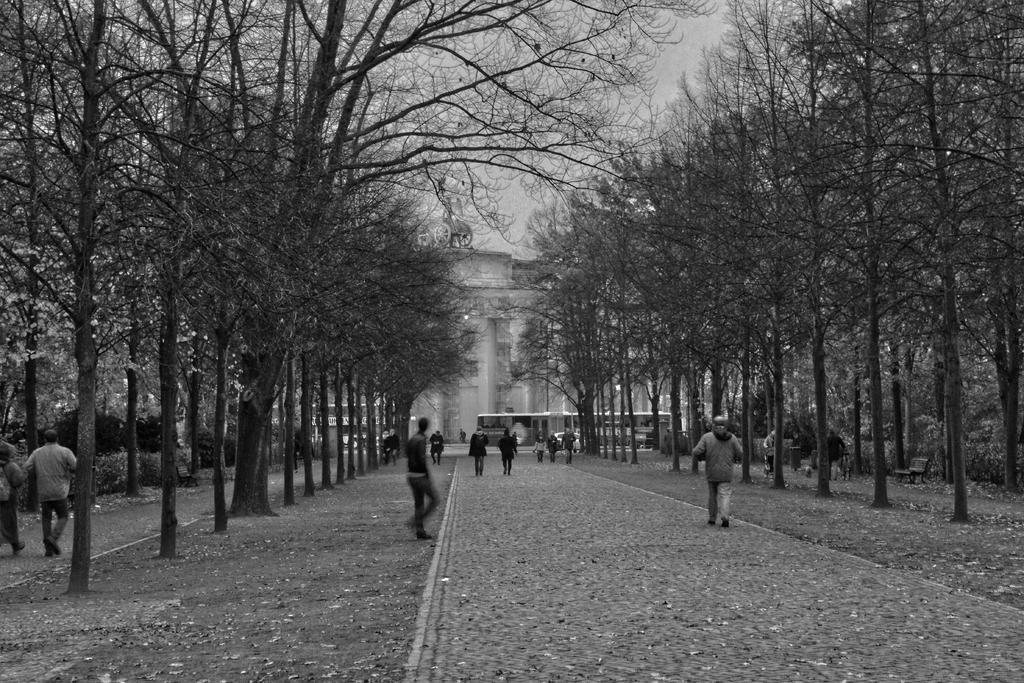In one or two sentences, can you explain what this image depicts? This is black and white image in this image people are walking on paths, on either side of the paths there are trees. 